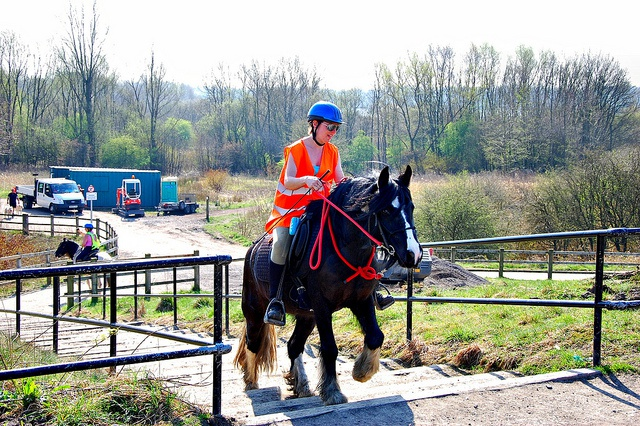Describe the objects in this image and their specific colors. I can see horse in white, black, navy, and gray tones, people in white, red, black, and darkgray tones, truck in white, blue, and navy tones, truck in white, black, navy, and lightblue tones, and horse in white, black, gray, and navy tones in this image. 